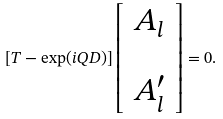Convert formula to latex. <formula><loc_0><loc_0><loc_500><loc_500>[ { T } - \exp ( i Q D ) ] \left [ \begin{array} { c } A _ { l } \\ \\ A ^ { \prime } _ { l } \\ \end{array} \right ] = 0 .</formula> 